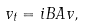Convert formula to latex. <formula><loc_0><loc_0><loc_500><loc_500>v _ { t } = i B A v ,</formula> 